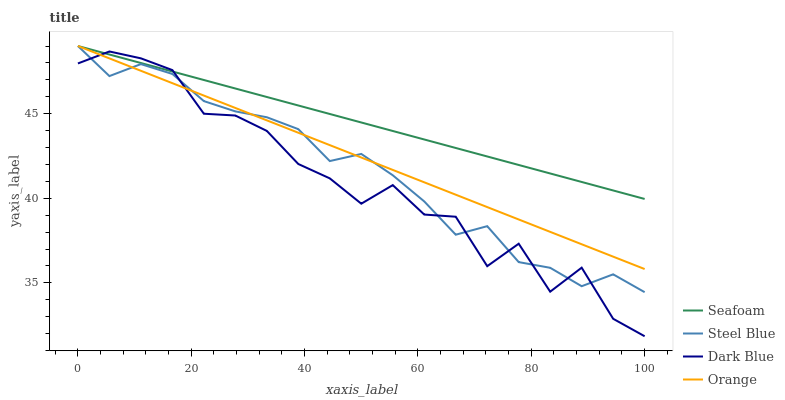Does Seafoam have the minimum area under the curve?
Answer yes or no. No. Does Dark Blue have the maximum area under the curve?
Answer yes or no. No. Is Seafoam the smoothest?
Answer yes or no. No. Is Seafoam the roughest?
Answer yes or no. No. Does Seafoam have the lowest value?
Answer yes or no. No. Does Dark Blue have the highest value?
Answer yes or no. No. 